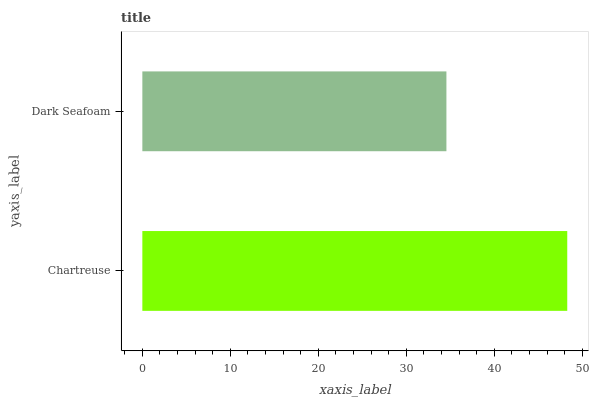Is Dark Seafoam the minimum?
Answer yes or no. Yes. Is Chartreuse the maximum?
Answer yes or no. Yes. Is Dark Seafoam the maximum?
Answer yes or no. No. Is Chartreuse greater than Dark Seafoam?
Answer yes or no. Yes. Is Dark Seafoam less than Chartreuse?
Answer yes or no. Yes. Is Dark Seafoam greater than Chartreuse?
Answer yes or no. No. Is Chartreuse less than Dark Seafoam?
Answer yes or no. No. Is Chartreuse the high median?
Answer yes or no. Yes. Is Dark Seafoam the low median?
Answer yes or no. Yes. Is Dark Seafoam the high median?
Answer yes or no. No. Is Chartreuse the low median?
Answer yes or no. No. 